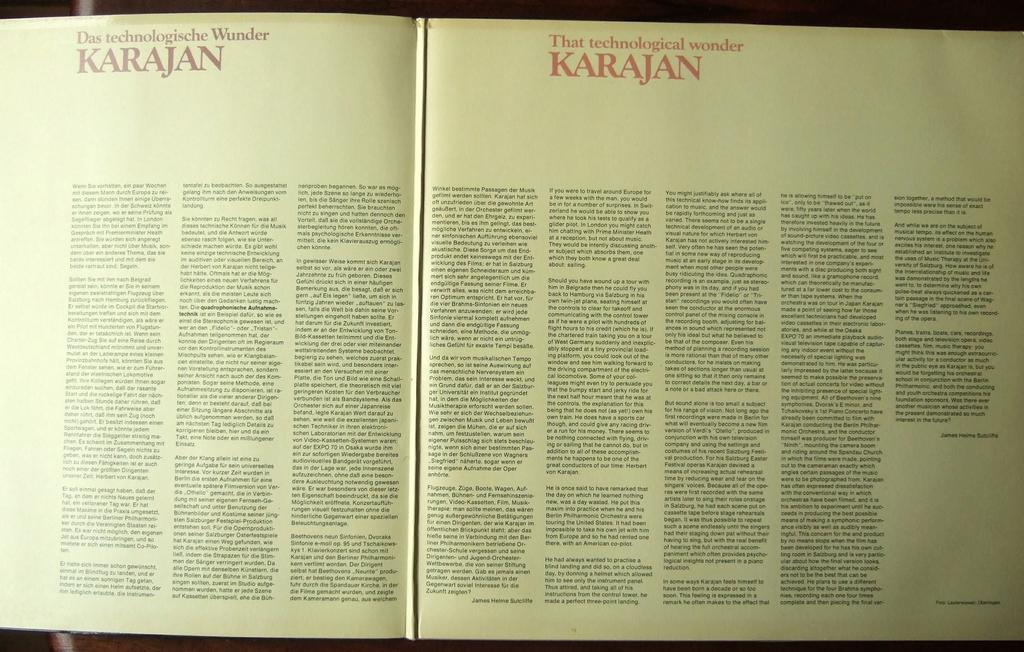Provide a one-sentence caption for the provided image. A text in German and English is about the technological wonder Karajan. 